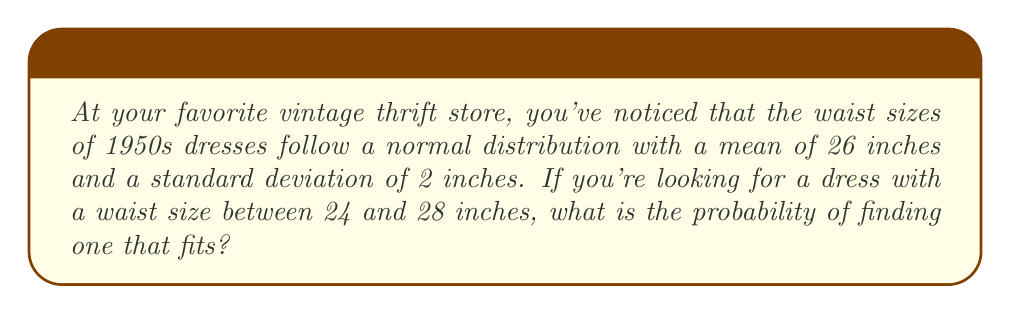Can you solve this math problem? Let's approach this step-by-step:

1) We're dealing with a normal distribution where:
   $\mu = 26$ inches (mean)
   $\sigma = 2$ inches (standard deviation)

2) We want to find the probability of a waist size between 24 and 28 inches.

3) To use the standard normal distribution, we need to standardize these values:
   For 24 inches: $z_1 = \frac{24 - 26}{2} = -1$
   For 28 inches: $z_2 = \frac{28 - 26}{2} = 1$

4) We're looking for $P(24 < X < 28)$, which is equivalent to $P(-1 < Z < 1)$ in the standard normal distribution.

5) Using the standard normal distribution table or a calculator:
   $P(Z < 1) = 0.8413$
   $P(Z < -1) = 0.1587$

6) The probability we're looking for is:
   $P(-1 < Z < 1) = P(Z < 1) - P(Z < -1) = 0.8413 - 0.1587 = 0.6826$

7) Convert to a percentage: $0.6826 \times 100\% = 68.26\%$

Therefore, there's a 68.26% chance of finding a 1950s dress with a waist size between 24 and 28 inches in this vintage thrift store.
Answer: 68.26% 